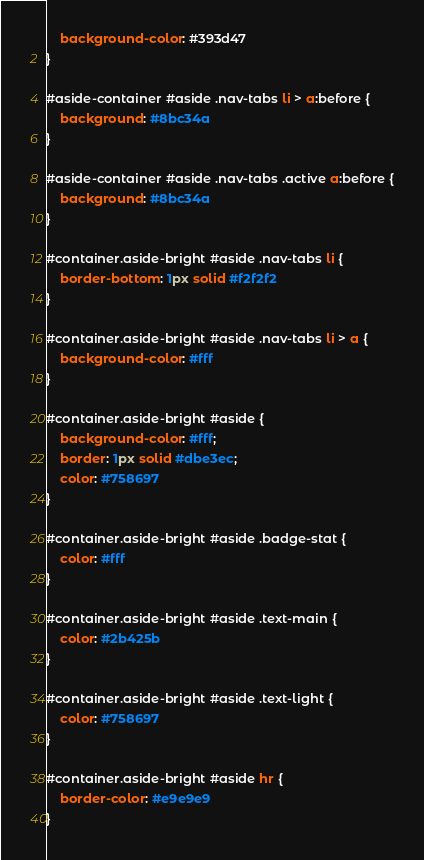<code> <loc_0><loc_0><loc_500><loc_500><_CSS_>    background-color: #393d47
}

#aside-container #aside .nav-tabs li > a:before {
    background: #8bc34a
}

#aside-container #aside .nav-tabs .active a:before {
    background: #8bc34a
}

#container.aside-bright #aside .nav-tabs li {
    border-bottom: 1px solid #f2f2f2
}

#container.aside-bright #aside .nav-tabs li > a {
    background-color: #fff
}

#container.aside-bright #aside {
    background-color: #fff;
    border: 1px solid #dbe3ec;
    color: #758697
}

#container.aside-bright #aside .badge-stat {
    color: #fff
}

#container.aside-bright #aside .text-main {
    color: #2b425b
}

#container.aside-bright #aside .text-light {
    color: #758697
}

#container.aside-bright #aside hr {
    border-color: #e9e9e9
}
</code> 